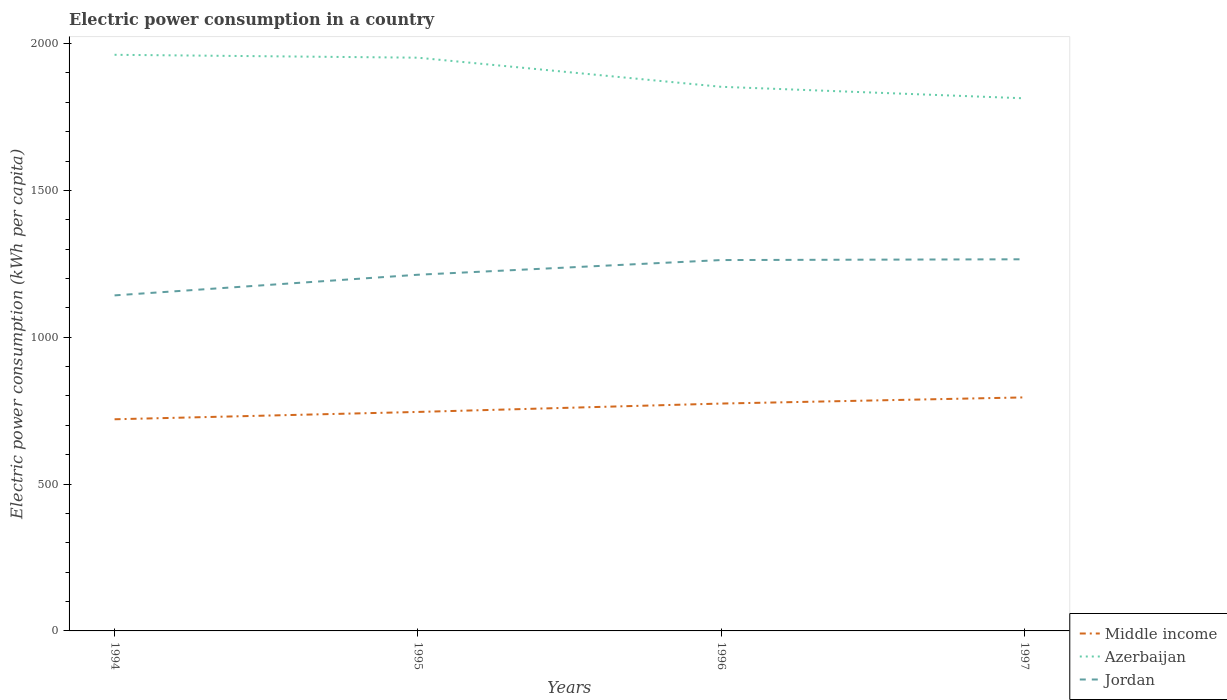Does the line corresponding to Azerbaijan intersect with the line corresponding to Jordan?
Offer a very short reply. No. Is the number of lines equal to the number of legend labels?
Keep it short and to the point. Yes. Across all years, what is the maximum electric power consumption in in Middle income?
Offer a terse response. 720.72. What is the total electric power consumption in in Middle income in the graph?
Keep it short and to the point. -49.51. What is the difference between the highest and the second highest electric power consumption in in Azerbaijan?
Provide a succinct answer. 148.16. What is the difference between the highest and the lowest electric power consumption in in Azerbaijan?
Ensure brevity in your answer.  2. How many lines are there?
Your answer should be compact. 3. How many years are there in the graph?
Keep it short and to the point. 4. Are the values on the major ticks of Y-axis written in scientific E-notation?
Offer a terse response. No. Does the graph contain any zero values?
Offer a terse response. No. How many legend labels are there?
Keep it short and to the point. 3. How are the legend labels stacked?
Provide a succinct answer. Vertical. What is the title of the graph?
Keep it short and to the point. Electric power consumption in a country. What is the label or title of the Y-axis?
Offer a terse response. Electric power consumption (kWh per capita). What is the Electric power consumption (kWh per capita) in Middle income in 1994?
Your response must be concise. 720.72. What is the Electric power consumption (kWh per capita) in Azerbaijan in 1994?
Provide a short and direct response. 1961.83. What is the Electric power consumption (kWh per capita) in Jordan in 1994?
Give a very brief answer. 1142.58. What is the Electric power consumption (kWh per capita) of Middle income in 1995?
Offer a terse response. 745.69. What is the Electric power consumption (kWh per capita) in Azerbaijan in 1995?
Make the answer very short. 1951.98. What is the Electric power consumption (kWh per capita) of Jordan in 1995?
Offer a terse response. 1212.87. What is the Electric power consumption (kWh per capita) of Middle income in 1996?
Give a very brief answer. 774.22. What is the Electric power consumption (kWh per capita) of Azerbaijan in 1996?
Provide a short and direct response. 1852.89. What is the Electric power consumption (kWh per capita) of Jordan in 1996?
Provide a succinct answer. 1262.89. What is the Electric power consumption (kWh per capita) of Middle income in 1997?
Your answer should be very brief. 795.2. What is the Electric power consumption (kWh per capita) in Azerbaijan in 1997?
Ensure brevity in your answer.  1813.67. What is the Electric power consumption (kWh per capita) in Jordan in 1997?
Give a very brief answer. 1265.53. Across all years, what is the maximum Electric power consumption (kWh per capita) in Middle income?
Offer a terse response. 795.2. Across all years, what is the maximum Electric power consumption (kWh per capita) of Azerbaijan?
Provide a succinct answer. 1961.83. Across all years, what is the maximum Electric power consumption (kWh per capita) in Jordan?
Make the answer very short. 1265.53. Across all years, what is the minimum Electric power consumption (kWh per capita) in Middle income?
Ensure brevity in your answer.  720.72. Across all years, what is the minimum Electric power consumption (kWh per capita) in Azerbaijan?
Your response must be concise. 1813.67. Across all years, what is the minimum Electric power consumption (kWh per capita) in Jordan?
Provide a short and direct response. 1142.58. What is the total Electric power consumption (kWh per capita) of Middle income in the graph?
Offer a very short reply. 3035.82. What is the total Electric power consumption (kWh per capita) of Azerbaijan in the graph?
Keep it short and to the point. 7580.37. What is the total Electric power consumption (kWh per capita) of Jordan in the graph?
Provide a succinct answer. 4883.86. What is the difference between the Electric power consumption (kWh per capita) in Middle income in 1994 and that in 1995?
Your response must be concise. -24.96. What is the difference between the Electric power consumption (kWh per capita) in Azerbaijan in 1994 and that in 1995?
Give a very brief answer. 9.84. What is the difference between the Electric power consumption (kWh per capita) in Jordan in 1994 and that in 1995?
Your answer should be very brief. -70.3. What is the difference between the Electric power consumption (kWh per capita) of Middle income in 1994 and that in 1996?
Provide a succinct answer. -53.49. What is the difference between the Electric power consumption (kWh per capita) of Azerbaijan in 1994 and that in 1996?
Keep it short and to the point. 108.94. What is the difference between the Electric power consumption (kWh per capita) of Jordan in 1994 and that in 1996?
Your response must be concise. -120.31. What is the difference between the Electric power consumption (kWh per capita) in Middle income in 1994 and that in 1997?
Give a very brief answer. -74.48. What is the difference between the Electric power consumption (kWh per capita) in Azerbaijan in 1994 and that in 1997?
Ensure brevity in your answer.  148.16. What is the difference between the Electric power consumption (kWh per capita) in Jordan in 1994 and that in 1997?
Provide a succinct answer. -122.95. What is the difference between the Electric power consumption (kWh per capita) of Middle income in 1995 and that in 1996?
Make the answer very short. -28.53. What is the difference between the Electric power consumption (kWh per capita) of Azerbaijan in 1995 and that in 1996?
Make the answer very short. 99.09. What is the difference between the Electric power consumption (kWh per capita) in Jordan in 1995 and that in 1996?
Provide a short and direct response. -50.02. What is the difference between the Electric power consumption (kWh per capita) in Middle income in 1995 and that in 1997?
Give a very brief answer. -49.51. What is the difference between the Electric power consumption (kWh per capita) of Azerbaijan in 1995 and that in 1997?
Ensure brevity in your answer.  138.31. What is the difference between the Electric power consumption (kWh per capita) of Jordan in 1995 and that in 1997?
Your answer should be compact. -52.65. What is the difference between the Electric power consumption (kWh per capita) of Middle income in 1996 and that in 1997?
Your answer should be very brief. -20.98. What is the difference between the Electric power consumption (kWh per capita) in Azerbaijan in 1996 and that in 1997?
Offer a terse response. 39.22. What is the difference between the Electric power consumption (kWh per capita) of Jordan in 1996 and that in 1997?
Provide a succinct answer. -2.64. What is the difference between the Electric power consumption (kWh per capita) of Middle income in 1994 and the Electric power consumption (kWh per capita) of Azerbaijan in 1995?
Provide a succinct answer. -1231.26. What is the difference between the Electric power consumption (kWh per capita) in Middle income in 1994 and the Electric power consumption (kWh per capita) in Jordan in 1995?
Keep it short and to the point. -492.15. What is the difference between the Electric power consumption (kWh per capita) in Azerbaijan in 1994 and the Electric power consumption (kWh per capita) in Jordan in 1995?
Keep it short and to the point. 748.95. What is the difference between the Electric power consumption (kWh per capita) of Middle income in 1994 and the Electric power consumption (kWh per capita) of Azerbaijan in 1996?
Provide a short and direct response. -1132.17. What is the difference between the Electric power consumption (kWh per capita) of Middle income in 1994 and the Electric power consumption (kWh per capita) of Jordan in 1996?
Give a very brief answer. -542.17. What is the difference between the Electric power consumption (kWh per capita) in Azerbaijan in 1994 and the Electric power consumption (kWh per capita) in Jordan in 1996?
Your answer should be very brief. 698.94. What is the difference between the Electric power consumption (kWh per capita) of Middle income in 1994 and the Electric power consumption (kWh per capita) of Azerbaijan in 1997?
Your answer should be very brief. -1092.95. What is the difference between the Electric power consumption (kWh per capita) of Middle income in 1994 and the Electric power consumption (kWh per capita) of Jordan in 1997?
Give a very brief answer. -544.8. What is the difference between the Electric power consumption (kWh per capita) of Azerbaijan in 1994 and the Electric power consumption (kWh per capita) of Jordan in 1997?
Keep it short and to the point. 696.3. What is the difference between the Electric power consumption (kWh per capita) in Middle income in 1995 and the Electric power consumption (kWh per capita) in Azerbaijan in 1996?
Your answer should be very brief. -1107.21. What is the difference between the Electric power consumption (kWh per capita) of Middle income in 1995 and the Electric power consumption (kWh per capita) of Jordan in 1996?
Keep it short and to the point. -517.2. What is the difference between the Electric power consumption (kWh per capita) of Azerbaijan in 1995 and the Electric power consumption (kWh per capita) of Jordan in 1996?
Give a very brief answer. 689.09. What is the difference between the Electric power consumption (kWh per capita) of Middle income in 1995 and the Electric power consumption (kWh per capita) of Azerbaijan in 1997?
Give a very brief answer. -1067.98. What is the difference between the Electric power consumption (kWh per capita) of Middle income in 1995 and the Electric power consumption (kWh per capita) of Jordan in 1997?
Your response must be concise. -519.84. What is the difference between the Electric power consumption (kWh per capita) of Azerbaijan in 1995 and the Electric power consumption (kWh per capita) of Jordan in 1997?
Ensure brevity in your answer.  686.46. What is the difference between the Electric power consumption (kWh per capita) of Middle income in 1996 and the Electric power consumption (kWh per capita) of Azerbaijan in 1997?
Keep it short and to the point. -1039.45. What is the difference between the Electric power consumption (kWh per capita) of Middle income in 1996 and the Electric power consumption (kWh per capita) of Jordan in 1997?
Give a very brief answer. -491.31. What is the difference between the Electric power consumption (kWh per capita) in Azerbaijan in 1996 and the Electric power consumption (kWh per capita) in Jordan in 1997?
Your response must be concise. 587.37. What is the average Electric power consumption (kWh per capita) of Middle income per year?
Offer a very short reply. 758.96. What is the average Electric power consumption (kWh per capita) in Azerbaijan per year?
Provide a succinct answer. 1895.09. What is the average Electric power consumption (kWh per capita) in Jordan per year?
Provide a short and direct response. 1220.97. In the year 1994, what is the difference between the Electric power consumption (kWh per capita) in Middle income and Electric power consumption (kWh per capita) in Azerbaijan?
Keep it short and to the point. -1241.1. In the year 1994, what is the difference between the Electric power consumption (kWh per capita) of Middle income and Electric power consumption (kWh per capita) of Jordan?
Your answer should be compact. -421.85. In the year 1994, what is the difference between the Electric power consumption (kWh per capita) in Azerbaijan and Electric power consumption (kWh per capita) in Jordan?
Offer a terse response. 819.25. In the year 1995, what is the difference between the Electric power consumption (kWh per capita) in Middle income and Electric power consumption (kWh per capita) in Azerbaijan?
Your answer should be very brief. -1206.3. In the year 1995, what is the difference between the Electric power consumption (kWh per capita) of Middle income and Electric power consumption (kWh per capita) of Jordan?
Offer a very short reply. -467.19. In the year 1995, what is the difference between the Electric power consumption (kWh per capita) of Azerbaijan and Electric power consumption (kWh per capita) of Jordan?
Give a very brief answer. 739.11. In the year 1996, what is the difference between the Electric power consumption (kWh per capita) in Middle income and Electric power consumption (kWh per capita) in Azerbaijan?
Your answer should be compact. -1078.68. In the year 1996, what is the difference between the Electric power consumption (kWh per capita) of Middle income and Electric power consumption (kWh per capita) of Jordan?
Your answer should be very brief. -488.67. In the year 1996, what is the difference between the Electric power consumption (kWh per capita) in Azerbaijan and Electric power consumption (kWh per capita) in Jordan?
Your answer should be very brief. 590. In the year 1997, what is the difference between the Electric power consumption (kWh per capita) of Middle income and Electric power consumption (kWh per capita) of Azerbaijan?
Ensure brevity in your answer.  -1018.47. In the year 1997, what is the difference between the Electric power consumption (kWh per capita) of Middle income and Electric power consumption (kWh per capita) of Jordan?
Make the answer very short. -470.33. In the year 1997, what is the difference between the Electric power consumption (kWh per capita) of Azerbaijan and Electric power consumption (kWh per capita) of Jordan?
Make the answer very short. 548.14. What is the ratio of the Electric power consumption (kWh per capita) of Middle income in 1994 to that in 1995?
Give a very brief answer. 0.97. What is the ratio of the Electric power consumption (kWh per capita) of Jordan in 1994 to that in 1995?
Your response must be concise. 0.94. What is the ratio of the Electric power consumption (kWh per capita) of Middle income in 1994 to that in 1996?
Ensure brevity in your answer.  0.93. What is the ratio of the Electric power consumption (kWh per capita) in Azerbaijan in 1994 to that in 1996?
Offer a terse response. 1.06. What is the ratio of the Electric power consumption (kWh per capita) in Jordan in 1994 to that in 1996?
Your response must be concise. 0.9. What is the ratio of the Electric power consumption (kWh per capita) of Middle income in 1994 to that in 1997?
Provide a short and direct response. 0.91. What is the ratio of the Electric power consumption (kWh per capita) in Azerbaijan in 1994 to that in 1997?
Offer a terse response. 1.08. What is the ratio of the Electric power consumption (kWh per capita) in Jordan in 1994 to that in 1997?
Your answer should be very brief. 0.9. What is the ratio of the Electric power consumption (kWh per capita) in Middle income in 1995 to that in 1996?
Offer a terse response. 0.96. What is the ratio of the Electric power consumption (kWh per capita) of Azerbaijan in 1995 to that in 1996?
Provide a succinct answer. 1.05. What is the ratio of the Electric power consumption (kWh per capita) of Jordan in 1995 to that in 1996?
Your response must be concise. 0.96. What is the ratio of the Electric power consumption (kWh per capita) in Middle income in 1995 to that in 1997?
Provide a short and direct response. 0.94. What is the ratio of the Electric power consumption (kWh per capita) of Azerbaijan in 1995 to that in 1997?
Offer a terse response. 1.08. What is the ratio of the Electric power consumption (kWh per capita) in Jordan in 1995 to that in 1997?
Make the answer very short. 0.96. What is the ratio of the Electric power consumption (kWh per capita) of Middle income in 1996 to that in 1997?
Your answer should be very brief. 0.97. What is the ratio of the Electric power consumption (kWh per capita) in Azerbaijan in 1996 to that in 1997?
Your answer should be very brief. 1.02. What is the ratio of the Electric power consumption (kWh per capita) in Jordan in 1996 to that in 1997?
Give a very brief answer. 1. What is the difference between the highest and the second highest Electric power consumption (kWh per capita) in Middle income?
Offer a terse response. 20.98. What is the difference between the highest and the second highest Electric power consumption (kWh per capita) in Azerbaijan?
Provide a short and direct response. 9.84. What is the difference between the highest and the second highest Electric power consumption (kWh per capita) in Jordan?
Your answer should be compact. 2.64. What is the difference between the highest and the lowest Electric power consumption (kWh per capita) in Middle income?
Offer a terse response. 74.48. What is the difference between the highest and the lowest Electric power consumption (kWh per capita) in Azerbaijan?
Provide a short and direct response. 148.16. What is the difference between the highest and the lowest Electric power consumption (kWh per capita) in Jordan?
Your answer should be very brief. 122.95. 